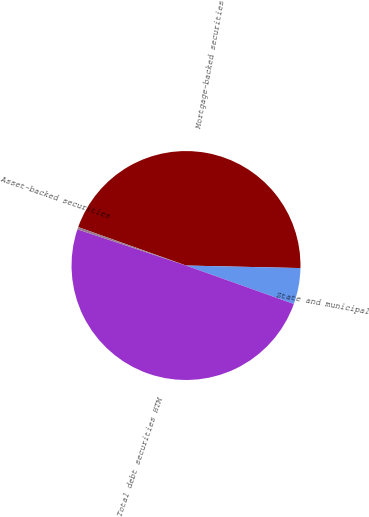Convert chart to OTSL. <chart><loc_0><loc_0><loc_500><loc_500><pie_chart><fcel>Mortgage-backed securities<fcel>State and municipal<fcel>Total debt securities HTM<fcel>Asset-backed securities<nl><fcel>44.9%<fcel>5.1%<fcel>49.67%<fcel>0.33%<nl></chart> 